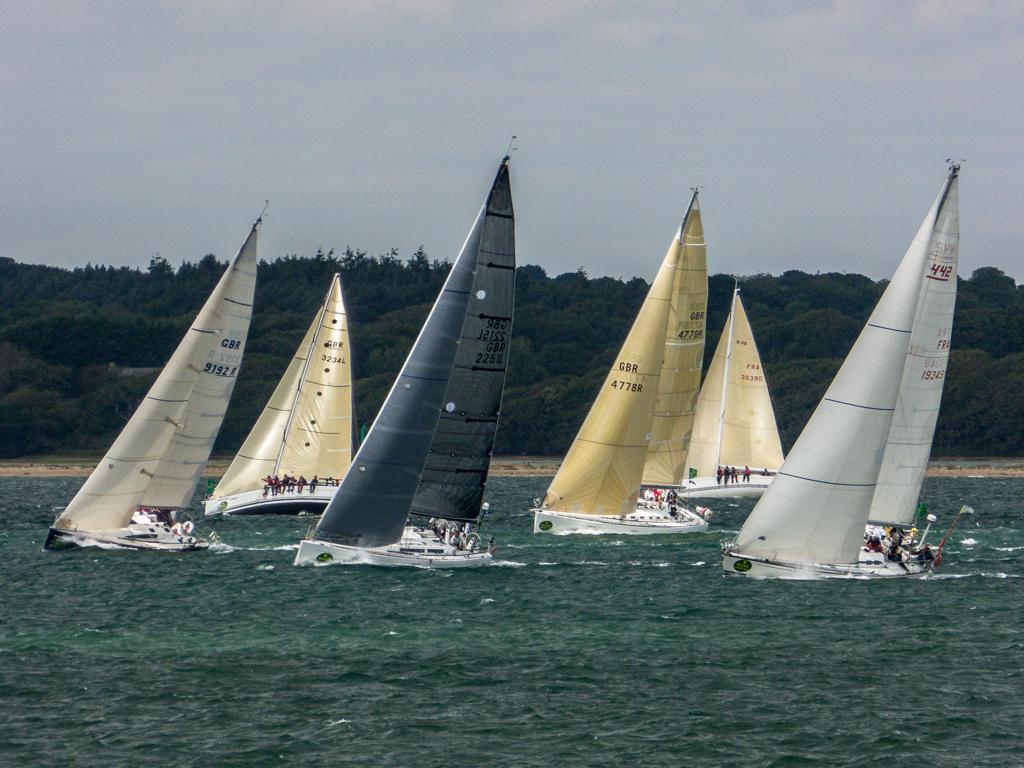How would you summarize this image in a sentence or two? In this image I can see the water and few board on the surface of the water which are white, black and cream in color. I can see few persons on the boats. In the background I can see few trees, the ground and the sky. 